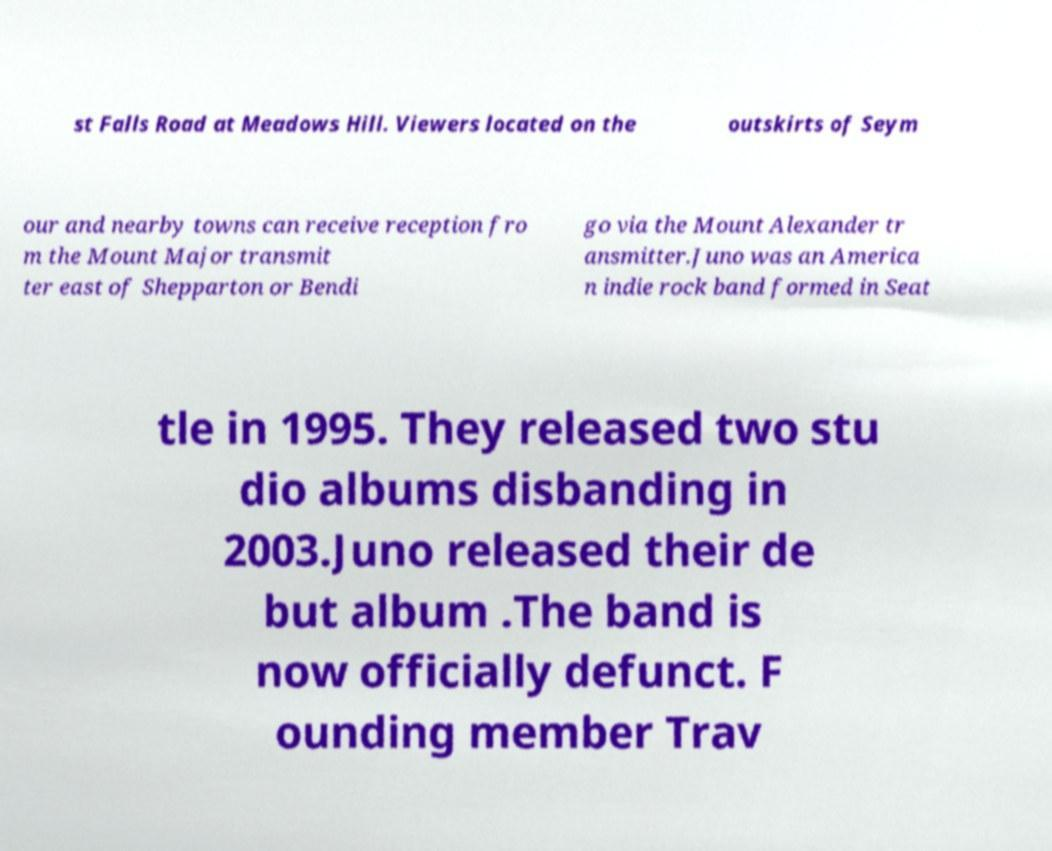Can you accurately transcribe the text from the provided image for me? st Falls Road at Meadows Hill. Viewers located on the outskirts of Seym our and nearby towns can receive reception fro m the Mount Major transmit ter east of Shepparton or Bendi go via the Mount Alexander tr ansmitter.Juno was an America n indie rock band formed in Seat tle in 1995. They released two stu dio albums disbanding in 2003.Juno released their de but album .The band is now officially defunct. F ounding member Trav 